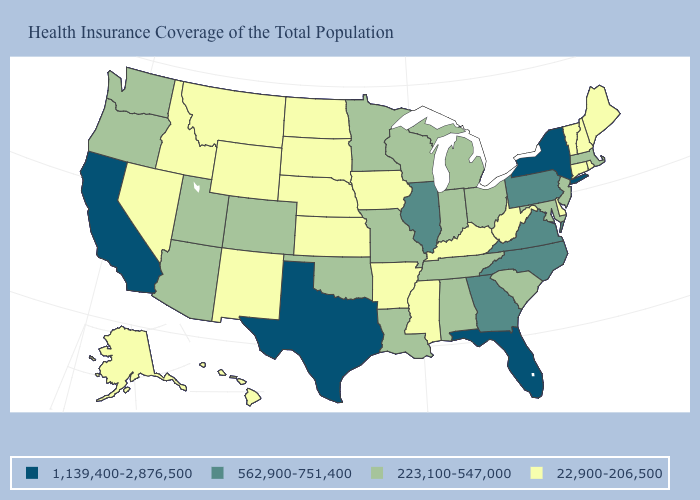Name the states that have a value in the range 223,100-547,000?
Short answer required. Alabama, Arizona, Colorado, Indiana, Louisiana, Maryland, Massachusetts, Michigan, Minnesota, Missouri, New Jersey, Ohio, Oklahoma, Oregon, South Carolina, Tennessee, Utah, Washington, Wisconsin. What is the lowest value in the USA?
Be succinct. 22,900-206,500. Among the states that border New York , which have the lowest value?
Short answer required. Connecticut, Vermont. Which states have the lowest value in the USA?
Be succinct. Alaska, Arkansas, Connecticut, Delaware, Hawaii, Idaho, Iowa, Kansas, Kentucky, Maine, Mississippi, Montana, Nebraska, Nevada, New Hampshire, New Mexico, North Dakota, Rhode Island, South Dakota, Vermont, West Virginia, Wyoming. Among the states that border North Carolina , which have the highest value?
Quick response, please. Georgia, Virginia. Which states have the highest value in the USA?
Quick response, please. California, Florida, New York, Texas. Does Texas have the highest value in the USA?
Give a very brief answer. Yes. What is the value of Michigan?
Concise answer only. 223,100-547,000. Which states hav the highest value in the South?
Write a very short answer. Florida, Texas. What is the value of Nevada?
Answer briefly. 22,900-206,500. What is the highest value in the USA?
Give a very brief answer. 1,139,400-2,876,500. Which states have the lowest value in the West?
Answer briefly. Alaska, Hawaii, Idaho, Montana, Nevada, New Mexico, Wyoming. Does New York have a higher value than Minnesota?
Quick response, please. Yes. Does the map have missing data?
Write a very short answer. No. Which states have the highest value in the USA?
Be succinct. California, Florida, New York, Texas. 